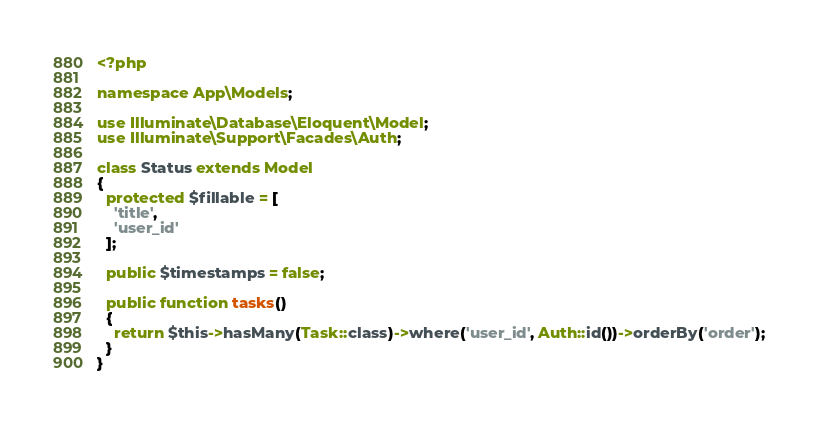Convert code to text. <code><loc_0><loc_0><loc_500><loc_500><_PHP_><?php

namespace App\Models;

use Illuminate\Database\Eloquent\Model;
use Illuminate\Support\Facades\Auth;

class Status extends Model
{
  protected $fillable = [
    'title',
    'user_id'
  ];

  public $timestamps = false;

  public function tasks()
  {
    return $this->hasMany(Task::class)->where('user_id', Auth::id())->orderBy('order');
  }
}
</code> 